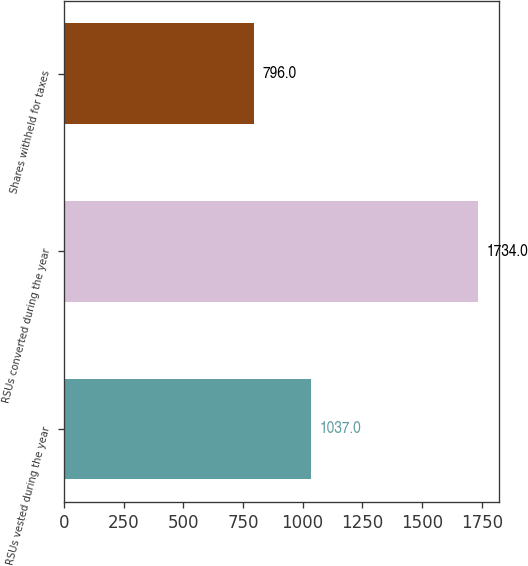Convert chart. <chart><loc_0><loc_0><loc_500><loc_500><bar_chart><fcel>RSUs vested during the year<fcel>RSUs converted during the year<fcel>Shares withheld for taxes<nl><fcel>1037<fcel>1734<fcel>796<nl></chart> 